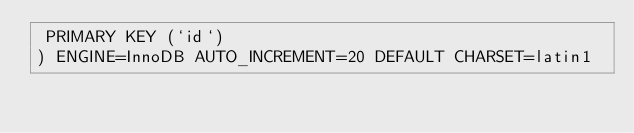Convert code to text. <code><loc_0><loc_0><loc_500><loc_500><_SQL_> PRIMARY KEY (`id`)
) ENGINE=InnoDB AUTO_INCREMENT=20 DEFAULT CHARSET=latin1</code> 